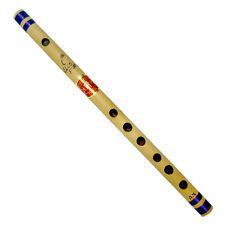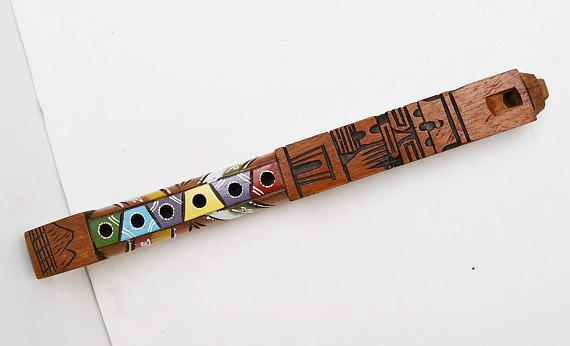The first image is the image on the left, the second image is the image on the right. For the images shown, is this caption "The flutes displayed on the left and right angle toward each other, and the flute on the right is decorated with tribal motifs." true? Answer yes or no. Yes. The first image is the image on the left, the second image is the image on the right. Given the left and right images, does the statement "Both flutes are angled from bottom left to top right." hold true? Answer yes or no. No. 